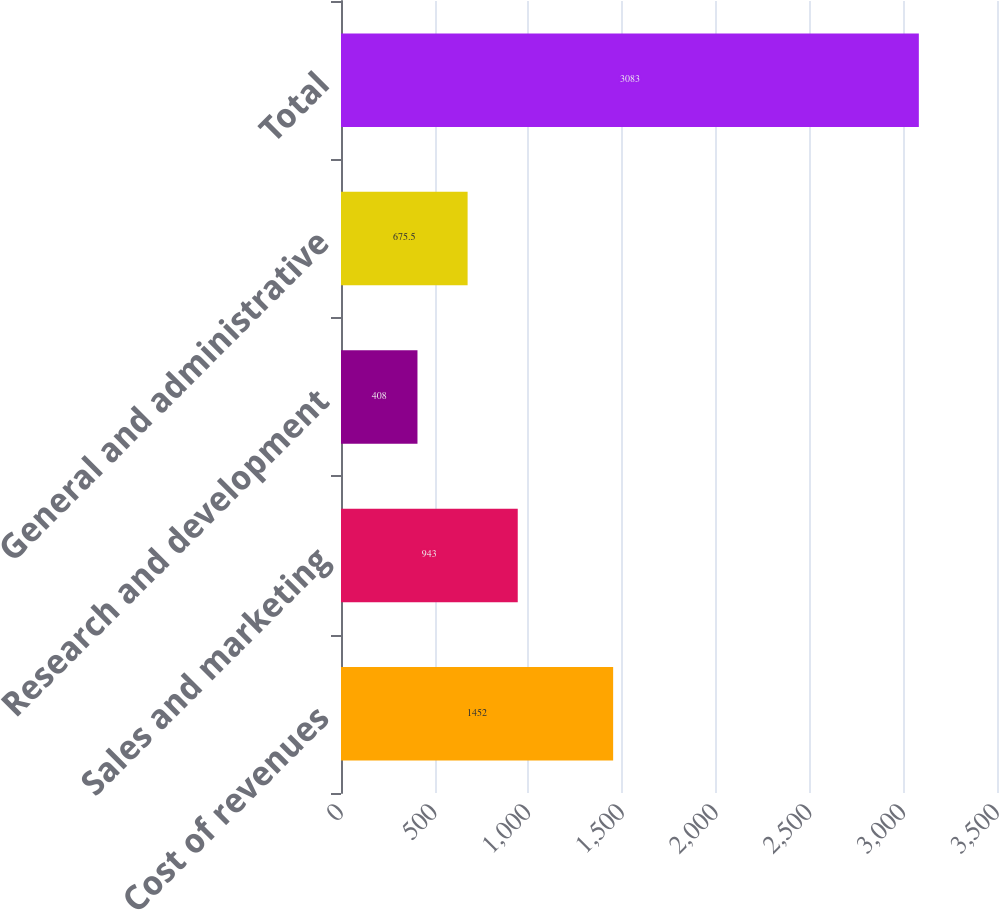Convert chart to OTSL. <chart><loc_0><loc_0><loc_500><loc_500><bar_chart><fcel>Cost of revenues<fcel>Sales and marketing<fcel>Research and development<fcel>General and administrative<fcel>Total<nl><fcel>1452<fcel>943<fcel>408<fcel>675.5<fcel>3083<nl></chart> 